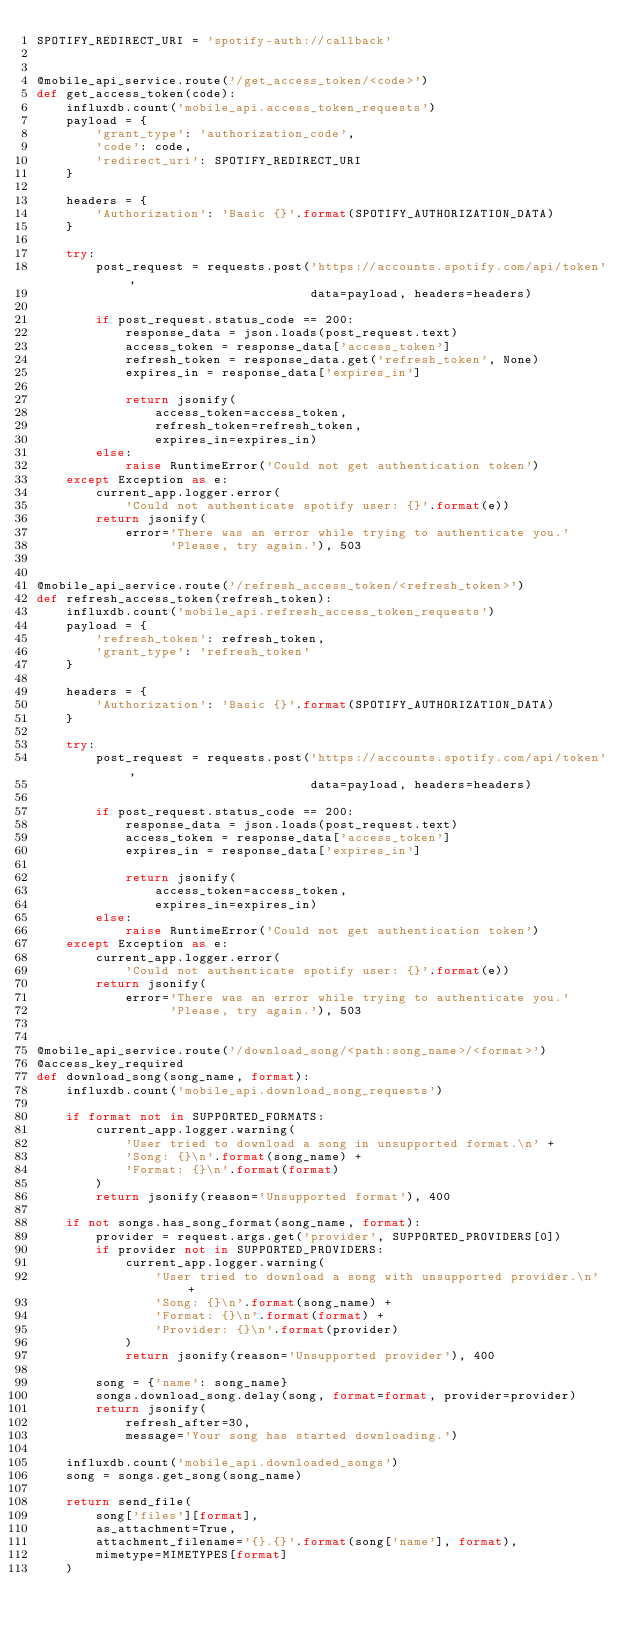<code> <loc_0><loc_0><loc_500><loc_500><_Python_>SPOTIFY_REDIRECT_URI = 'spotify-auth://callback'


@mobile_api_service.route('/get_access_token/<code>')
def get_access_token(code):
    influxdb.count('mobile_api.access_token_requests')
    payload = {
        'grant_type': 'authorization_code',
        'code': code,
        'redirect_uri': SPOTIFY_REDIRECT_URI
    }

    headers = {
        'Authorization': 'Basic {}'.format(SPOTIFY_AUTHORIZATION_DATA)
    }

    try:
        post_request = requests.post('https://accounts.spotify.com/api/token',
                                     data=payload, headers=headers)

        if post_request.status_code == 200:
            response_data = json.loads(post_request.text)
            access_token = response_data['access_token']
            refresh_token = response_data.get('refresh_token', None)
            expires_in = response_data['expires_in']

            return jsonify(
                access_token=access_token,
                refresh_token=refresh_token,
                expires_in=expires_in)
        else:
            raise RuntimeError('Could not get authentication token')
    except Exception as e:
        current_app.logger.error(
            'Could not authenticate spotify user: {}'.format(e))
        return jsonify(
            error='There was an error while trying to authenticate you.'
                  'Please, try again.'), 503


@mobile_api_service.route('/refresh_access_token/<refresh_token>')
def refresh_access_token(refresh_token):
    influxdb.count('mobile_api.refresh_access_token_requests')
    payload = {
        'refresh_token': refresh_token,
        'grant_type': 'refresh_token'
    }

    headers = {
        'Authorization': 'Basic {}'.format(SPOTIFY_AUTHORIZATION_DATA)
    }

    try:
        post_request = requests.post('https://accounts.spotify.com/api/token',
                                     data=payload, headers=headers)

        if post_request.status_code == 200:
            response_data = json.loads(post_request.text)
            access_token = response_data['access_token']
            expires_in = response_data['expires_in']

            return jsonify(
                access_token=access_token,
                expires_in=expires_in)
        else:
            raise RuntimeError('Could not get authentication token')
    except Exception as e:
        current_app.logger.error(
            'Could not authenticate spotify user: {}'.format(e))
        return jsonify(
            error='There was an error while trying to authenticate you.'
                  'Please, try again.'), 503


@mobile_api_service.route('/download_song/<path:song_name>/<format>')
@access_key_required
def download_song(song_name, format):
    influxdb.count('mobile_api.download_song_requests')

    if format not in SUPPORTED_FORMATS:
        current_app.logger.warning(
            'User tried to download a song in unsupported format.\n' +
            'Song: {}\n'.format(song_name) +
            'Format: {}\n'.format(format)
        )
        return jsonify(reason='Unsupported format'), 400

    if not songs.has_song_format(song_name, format):
        provider = request.args.get('provider', SUPPORTED_PROVIDERS[0])
        if provider not in SUPPORTED_PROVIDERS:
            current_app.logger.warning(
                'User tried to download a song with unsupported provider.\n' +
                'Song: {}\n'.format(song_name) +
                'Format: {}\n'.format(format) +
                'Provider: {}\n'.format(provider)
            )
            return jsonify(reason='Unsupported provider'), 400

        song = {'name': song_name}
        songs.download_song.delay(song, format=format, provider=provider)
        return jsonify(
            refresh_after=30,
            message='Your song has started downloading.')

    influxdb.count('mobile_api.downloaded_songs')
    song = songs.get_song(song_name)

    return send_file(
        song['files'][format],
        as_attachment=True,
        attachment_filename='{}.{}'.format(song['name'], format),
        mimetype=MIMETYPES[format]
    )
</code> 